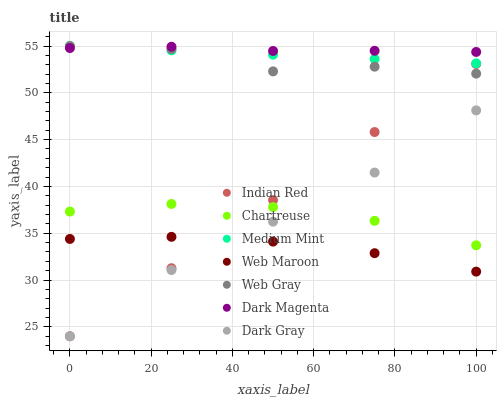Does Web Maroon have the minimum area under the curve?
Answer yes or no. Yes. Does Dark Magenta have the maximum area under the curve?
Answer yes or no. Yes. Does Web Gray have the minimum area under the curve?
Answer yes or no. No. Does Web Gray have the maximum area under the curve?
Answer yes or no. No. Is Indian Red the smoothest?
Answer yes or no. Yes. Is Web Gray the roughest?
Answer yes or no. Yes. Is Dark Magenta the smoothest?
Answer yes or no. No. Is Dark Magenta the roughest?
Answer yes or no. No. Does Dark Gray have the lowest value?
Answer yes or no. Yes. Does Web Gray have the lowest value?
Answer yes or no. No. Does Web Gray have the highest value?
Answer yes or no. Yes. Does Dark Magenta have the highest value?
Answer yes or no. No. Is Dark Gray less than Dark Magenta?
Answer yes or no. Yes. Is Medium Mint greater than Dark Gray?
Answer yes or no. Yes. Does Indian Red intersect Chartreuse?
Answer yes or no. Yes. Is Indian Red less than Chartreuse?
Answer yes or no. No. Is Indian Red greater than Chartreuse?
Answer yes or no. No. Does Dark Gray intersect Dark Magenta?
Answer yes or no. No. 